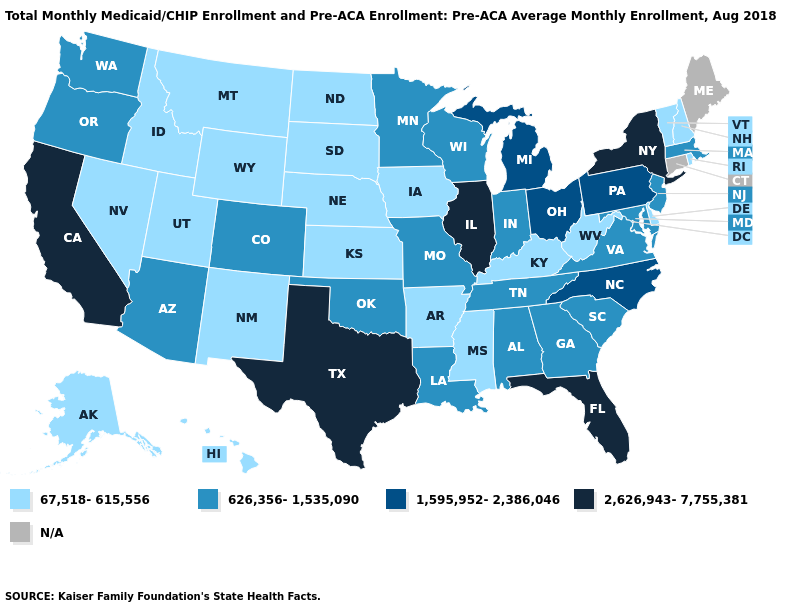What is the lowest value in the USA?
Be succinct. 67,518-615,556. What is the value of Montana?
Concise answer only. 67,518-615,556. Does California have the highest value in the West?
Write a very short answer. Yes. What is the lowest value in states that border Arkansas?
Quick response, please. 67,518-615,556. Does Oregon have the lowest value in the West?
Give a very brief answer. No. Name the states that have a value in the range 2,626,943-7,755,381?
Keep it brief. California, Florida, Illinois, New York, Texas. What is the highest value in the USA?
Write a very short answer. 2,626,943-7,755,381. Which states hav the highest value in the West?
Answer briefly. California. What is the lowest value in the MidWest?
Answer briefly. 67,518-615,556. What is the lowest value in the USA?
Quick response, please. 67,518-615,556. Among the states that border Louisiana , which have the lowest value?
Write a very short answer. Arkansas, Mississippi. Name the states that have a value in the range 626,356-1,535,090?
Write a very short answer. Alabama, Arizona, Colorado, Georgia, Indiana, Louisiana, Maryland, Massachusetts, Minnesota, Missouri, New Jersey, Oklahoma, Oregon, South Carolina, Tennessee, Virginia, Washington, Wisconsin. Which states hav the highest value in the MidWest?
Concise answer only. Illinois. Does Texas have the highest value in the USA?
Be succinct. Yes. What is the value of Mississippi?
Write a very short answer. 67,518-615,556. 